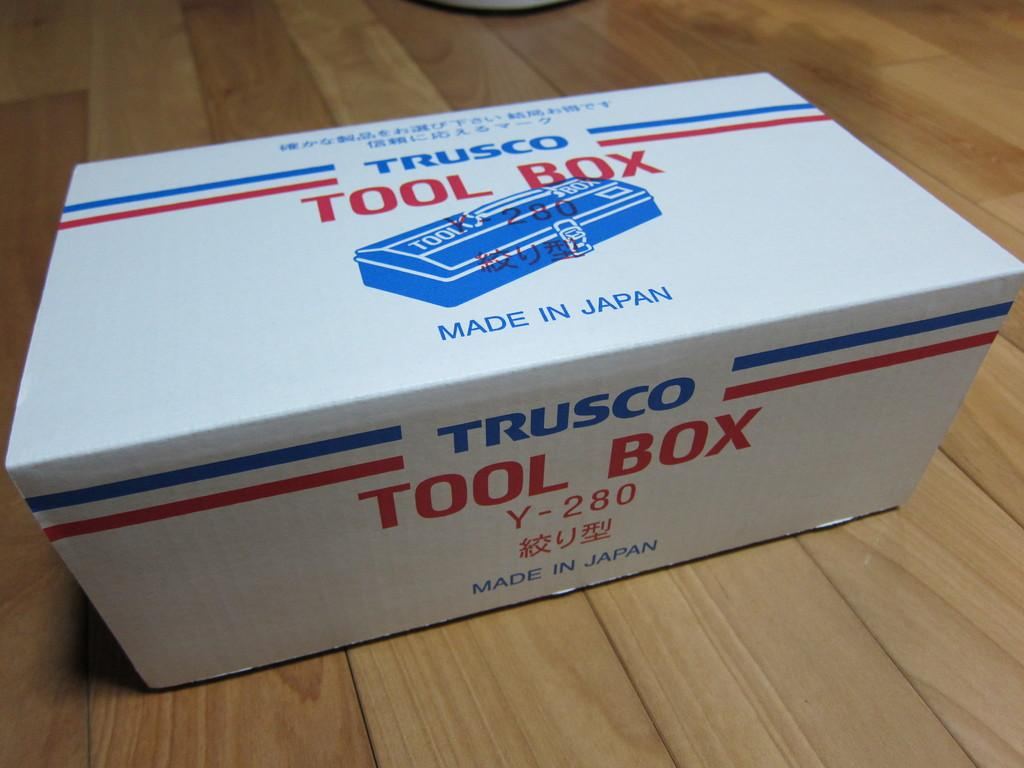Provide a one-sentence caption for the provided image. A box made in Japan by Trusco with a Tool Box inside. 